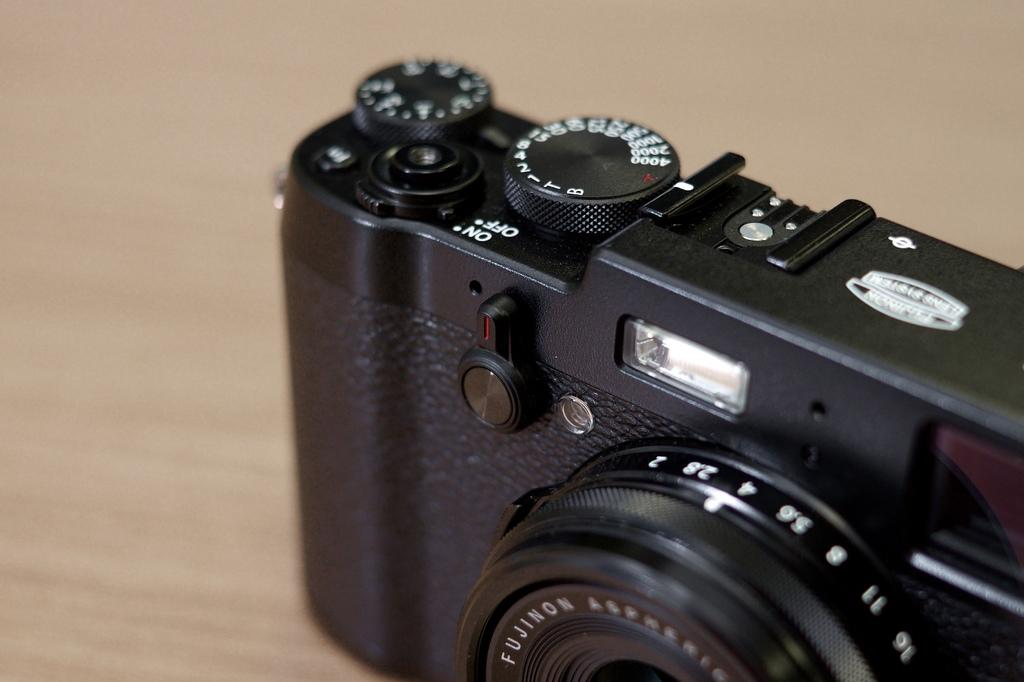<image>
Describe the image concisely. A SLR camera with an on and off switch 